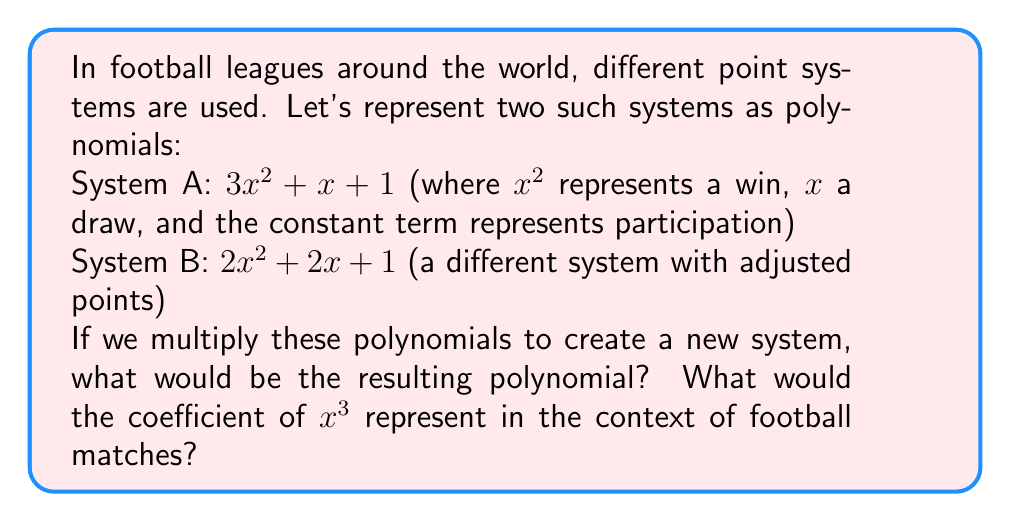Give your solution to this math problem. Let's multiply the polynomials step by step:

$(3x^2 + x + 1)(2x^2 + 2x + 1)$

1) First, distribute $3x^2$:
   $3x^2(2x^2) = 6x^4$
   $3x^2(2x) = 6x^3$
   $3x^2(1) = 3x^2$

2) Next, distribute $x$:
   $x(2x^2) = 2x^3$
   $x(2x) = 2x^2$
   $x(1) = x$

3) Finally, distribute the constant term 1:
   $1(2x^2) = 2x^2$
   $1(2x) = 2x$
   $1(1) = 1$

4) Now, sum all terms:
   $6x^4 + 6x^3 + 3x^2 + 2x^3 + 2x^2 + x + 2x^2 + 2x + 1$

5) Combine like terms:
   $6x^4 + 8x^3 + 7x^2 + 3x + 1$

In the context of football matches, the coefficient of $x^3$ (which is 8) would represent the points awarded for a combination of outcomes that contribute three factors to the total points. This could be interpreted as the points awarded for a win in one system combined with a draw in the other system.
Answer: $6x^4 + 8x^3 + 7x^2 + 3x + 1$ 